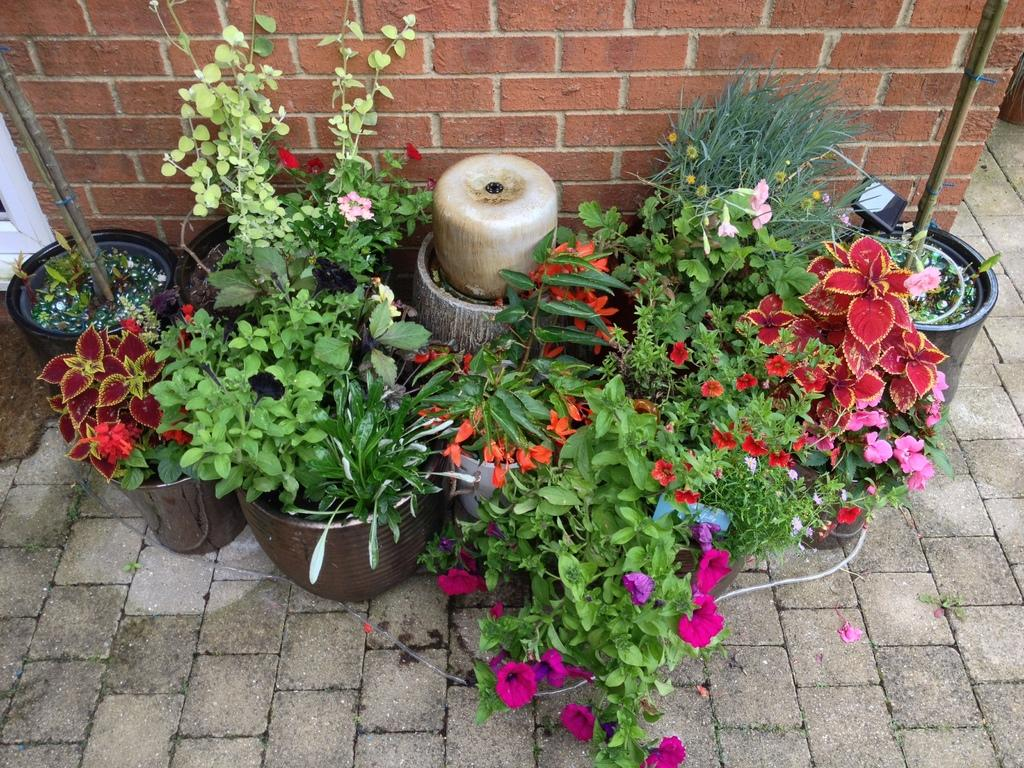What type of plants are in the image? There are potted plants in the image. Where are the potted plants located in relation to other elements in the image? The potted plants are placed beside a wall. What type of brush can be seen cleaning the potted plants in the image? There is no brush present in the image, and the potted plants are not being cleaned. 